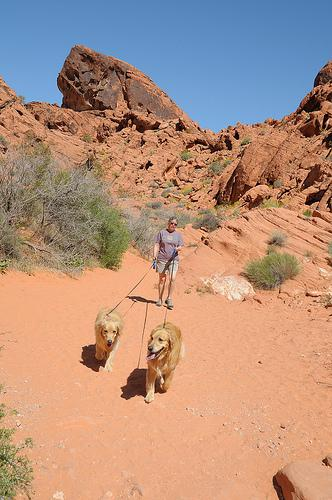Question: how many dogs are there?
Choices:
A. 1.
B. 3.
C. 4.
D. 2.
Answer with the letter. Answer: D Question: what is the man doing?
Choices:
A. Flying a plane.
B. Walking his dogs.
C. Watering plants.
D. Eating lunch.
Answer with the letter. Answer: B Question: what are they walking on?
Choices:
A. A road.
B. A sidewalk.
C. A tile floor.
D. A mountain path.
Answer with the letter. Answer: D Question: why are the dogs panting?
Choices:
A. They are excited.
B. They need water.
C. They need air.
D. They are hot.
Answer with the letter. Answer: D Question: when was the photo taken?
Choices:
A. At night.
B. Noon.
C. Morning.
D. During the day.
Answer with the letter. Answer: D Question: where are there?
Choices:
A. In the forest.
B. On the beach.
C. In the desert.
D. On a mountain path.
Answer with the letter. Answer: D Question: who is walking his dogs?
Choices:
A. The woman.
B. A man.
C. A professional dog walker.
D. The boy.
Answer with the letter. Answer: B 